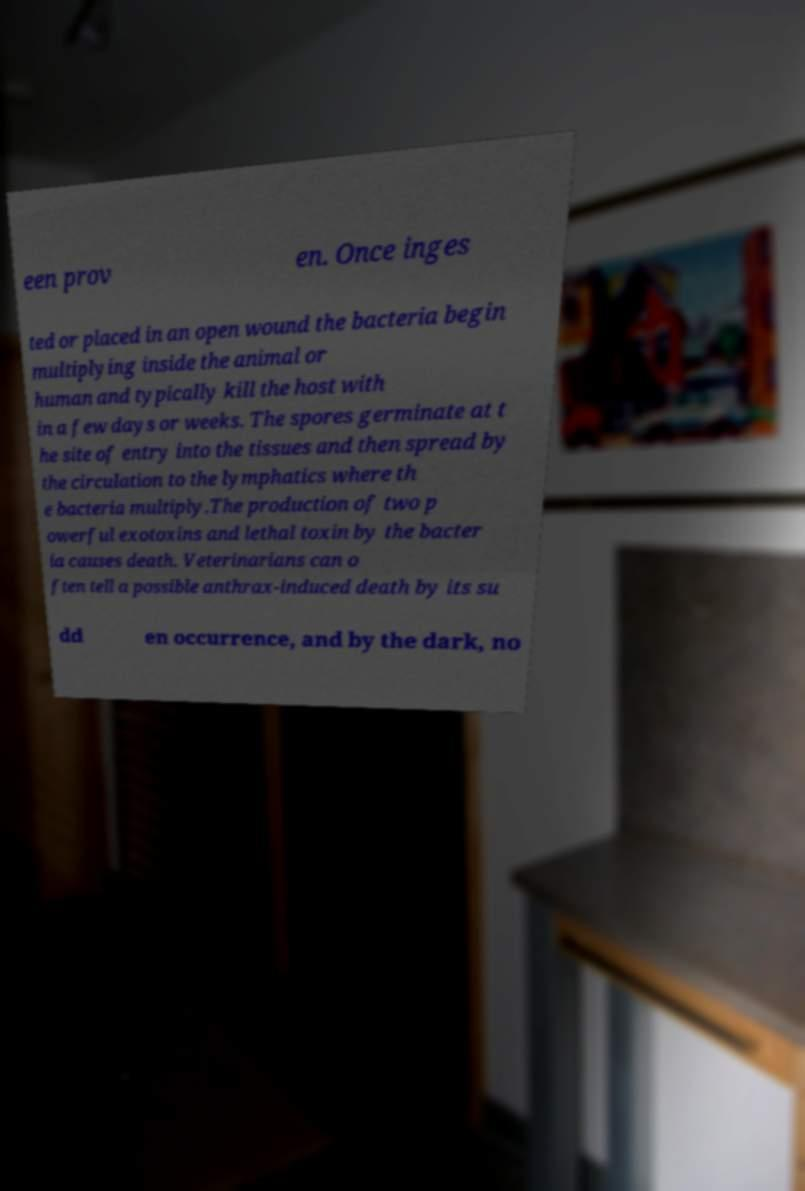Could you assist in decoding the text presented in this image and type it out clearly? een prov en. Once inges ted or placed in an open wound the bacteria begin multiplying inside the animal or human and typically kill the host with in a few days or weeks. The spores germinate at t he site of entry into the tissues and then spread by the circulation to the lymphatics where th e bacteria multiply.The production of two p owerful exotoxins and lethal toxin by the bacter ia causes death. Veterinarians can o ften tell a possible anthrax-induced death by its su dd en occurrence, and by the dark, no 